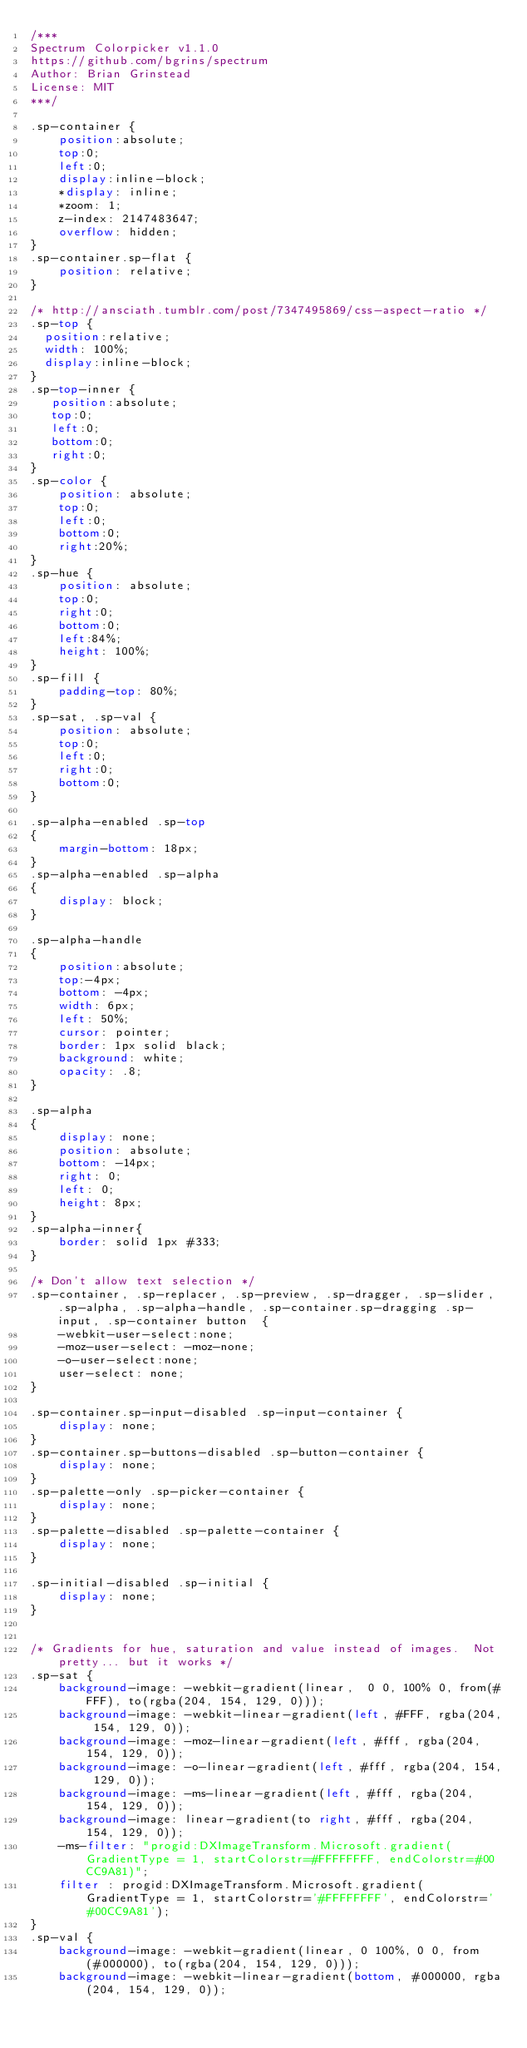<code> <loc_0><loc_0><loc_500><loc_500><_CSS_>/***
Spectrum Colorpicker v1.1.0
https://github.com/bgrins/spectrum
Author: Brian Grinstead
License: MIT
***/

.sp-container {
    position:absolute;
    top:0;
    left:0;
    display:inline-block;
    *display: inline;
    *zoom: 1;
    z-index: 2147483647;
    overflow: hidden;
}
.sp-container.sp-flat {
    position: relative;
}

/* http://ansciath.tumblr.com/post/7347495869/css-aspect-ratio */
.sp-top {
  position:relative;
  width: 100%;
  display:inline-block;
}
.sp-top-inner {
   position:absolute;
   top:0;
   left:0;
   bottom:0;
   right:0;
}
.sp-color {
    position: absolute;
    top:0;
    left:0;
    bottom:0;
    right:20%;
}
.sp-hue {
    position: absolute;
    top:0;
    right:0;
    bottom:0;
    left:84%;
    height: 100%;
}
.sp-fill {
    padding-top: 80%;
}
.sp-sat, .sp-val {
    position: absolute;
    top:0;
    left:0;
    right:0;
    bottom:0;
}

.sp-alpha-enabled .sp-top
{
    margin-bottom: 18px;
}
.sp-alpha-enabled .sp-alpha
{
    display: block;
}

.sp-alpha-handle
{
    position:absolute;
    top:-4px;
    bottom: -4px;
    width: 6px;
    left: 50%;
    cursor: pointer;
    border: 1px solid black;
    background: white;
    opacity: .8;
}

.sp-alpha
{
    display: none;
    position: absolute;
    bottom: -14px;
    right: 0;
    left: 0;
    height: 8px;
}
.sp-alpha-inner{
    border: solid 1px #333;
}

/* Don't allow text selection */
.sp-container, .sp-replacer, .sp-preview, .sp-dragger, .sp-slider, .sp-alpha, .sp-alpha-handle, .sp-container.sp-dragging .sp-input, .sp-container button  {
    -webkit-user-select:none;
    -moz-user-select: -moz-none;
    -o-user-select:none;
    user-select: none;
}

.sp-container.sp-input-disabled .sp-input-container {
    display: none;
}
.sp-container.sp-buttons-disabled .sp-button-container {
    display: none;
}
.sp-palette-only .sp-picker-container {
    display: none;
}
.sp-palette-disabled .sp-palette-container {
    display: none;
}

.sp-initial-disabled .sp-initial {
    display: none;
}


/* Gradients for hue, saturation and value instead of images.  Not pretty... but it works */
.sp-sat {
    background-image: -webkit-gradient(linear,  0 0, 100% 0, from(#FFF), to(rgba(204, 154, 129, 0)));
    background-image: -webkit-linear-gradient(left, #FFF, rgba(204, 154, 129, 0));
    background-image: -moz-linear-gradient(left, #fff, rgba(204, 154, 129, 0));
    background-image: -o-linear-gradient(left, #fff, rgba(204, 154, 129, 0));
    background-image: -ms-linear-gradient(left, #fff, rgba(204, 154, 129, 0));
    background-image: linear-gradient(to right, #fff, rgba(204, 154, 129, 0));
    -ms-filter: "progid:DXImageTransform.Microsoft.gradient(GradientType = 1, startColorstr=#FFFFFFFF, endColorstr=#00CC9A81)";
    filter : progid:DXImageTransform.Microsoft.gradient(GradientType = 1, startColorstr='#FFFFFFFF', endColorstr='#00CC9A81');
}
.sp-val {
    background-image: -webkit-gradient(linear, 0 100%, 0 0, from(#000000), to(rgba(204, 154, 129, 0)));
    background-image: -webkit-linear-gradient(bottom, #000000, rgba(204, 154, 129, 0));</code> 